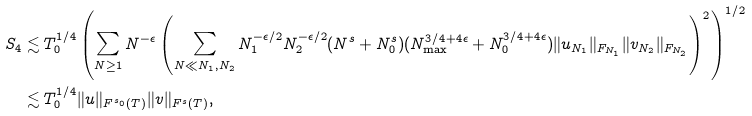Convert formula to latex. <formula><loc_0><loc_0><loc_500><loc_500>S _ { 4 } & \lesssim T ^ { 1 / 4 } _ { 0 } \left ( \sum _ { N \geq 1 } N ^ { - \epsilon } \left ( \sum _ { N \ll N _ { 1 } , N _ { 2 } } N _ { 1 } ^ { - \epsilon / 2 } N _ { 2 } ^ { - \epsilon / 2 } ( N ^ { s } + N _ { 0 } ^ { s } ) ( N _ { \max } ^ { 3 / 4 + 4 \epsilon } + N _ { 0 } ^ { 3 / 4 + 4 \epsilon } ) \| u _ { N _ { 1 } } \| _ { F _ { N _ { 1 } } } \| v _ { N _ { 2 } } \| _ { F _ { N _ { 2 } } } \right ) ^ { 2 } \right ) ^ { 1 / 2 } \\ & \lesssim T ^ { 1 / 4 } _ { 0 } \| u \| _ { F ^ { s _ { 0 } } ( T ) } \| v \| _ { F ^ { s } ( T ) } ,</formula> 